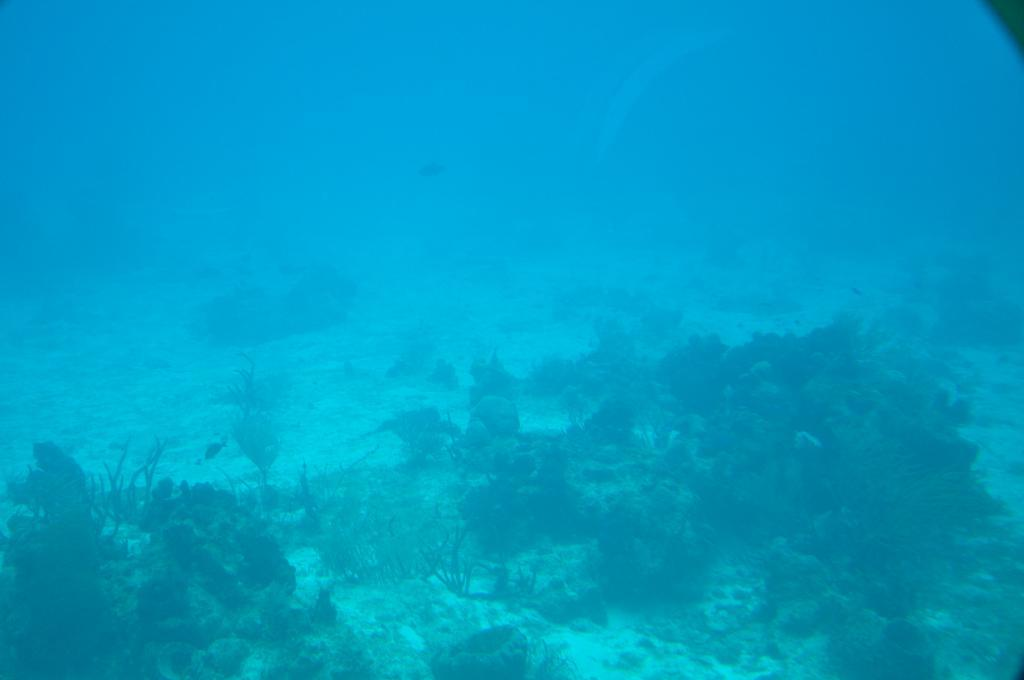Where was the image taken? The image is taken under the sea. What types of vegetation can be seen in the image? There are plants in the image. What other natural elements are present in the image? There are rocks in the image. What kind of marine life can be observed in the image? There are fish in the water. What type of prose is being recited by the duck in the image? There is no duck present in the image, and therefore no prose being recited. 